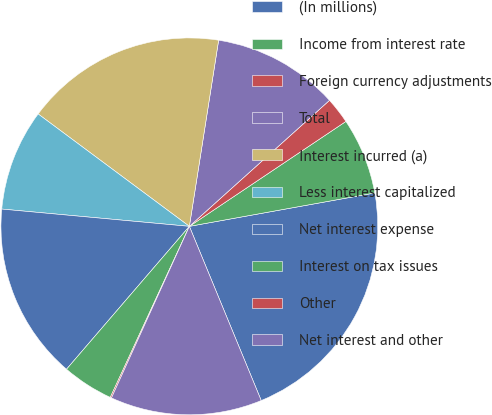Convert chart to OTSL. <chart><loc_0><loc_0><loc_500><loc_500><pie_chart><fcel>(In millions)<fcel>Income from interest rate<fcel>Foreign currency adjustments<fcel>Total<fcel>Interest incurred (a)<fcel>Less interest capitalized<fcel>Net interest expense<fcel>Interest on tax issues<fcel>Other<fcel>Net interest and other<nl><fcel>21.61%<fcel>6.56%<fcel>2.26%<fcel>10.86%<fcel>17.31%<fcel>8.71%<fcel>15.16%<fcel>4.41%<fcel>0.11%<fcel>13.01%<nl></chart> 